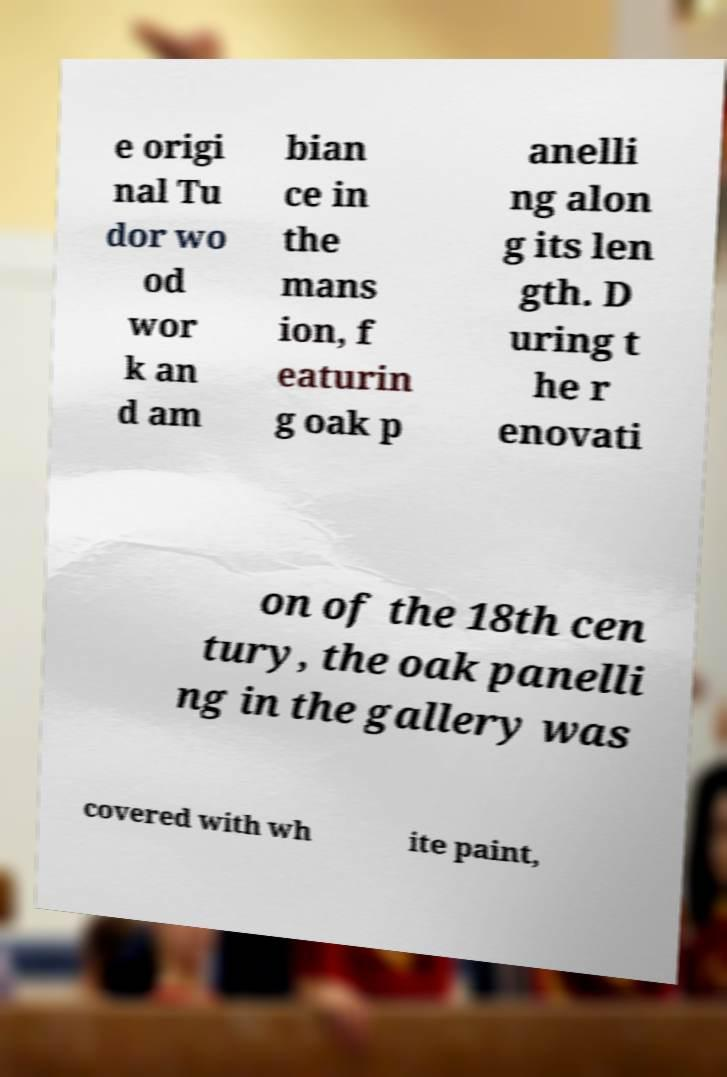Could you assist in decoding the text presented in this image and type it out clearly? e origi nal Tu dor wo od wor k an d am bian ce in the mans ion, f eaturin g oak p anelli ng alon g its len gth. D uring t he r enovati on of the 18th cen tury, the oak panelli ng in the gallery was covered with wh ite paint, 